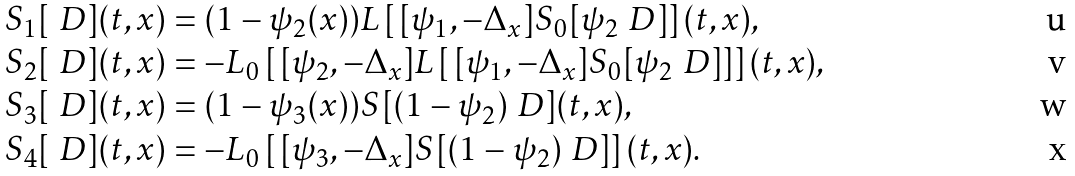<formula> <loc_0><loc_0><loc_500><loc_500>& S _ { 1 } [ \ D ] ( t , x ) = ( 1 - \psi _ { 2 } ( x ) ) L \left [ \, [ \psi _ { 1 } , - \Delta _ { x } ] S _ { 0 } [ \psi _ { 2 } \ D ] \right ] ( t , x ) , \\ & S _ { 2 } [ \ D ] ( t , x ) = - L _ { 0 } \left [ \, [ \psi _ { 2 } , - \Delta _ { x } ] L \left [ \, [ \psi _ { 1 } , - \Delta _ { x } ] S _ { 0 } [ \psi _ { 2 } \ D ] \right ] \right ] ( t , x ) , \\ & S _ { 3 } [ \ D ] ( t , x ) = ( 1 - \psi _ { 3 } ( x ) ) S [ ( 1 - \psi _ { 2 } ) \ D ] ( t , x ) , \\ & S _ { 4 } [ \ D ] ( t , x ) = - L _ { 0 } \left [ \, [ \psi _ { 3 } , - \Delta _ { x } ] S [ ( 1 - \psi _ { 2 } ) \ D ] \right ] ( t , x ) .</formula> 